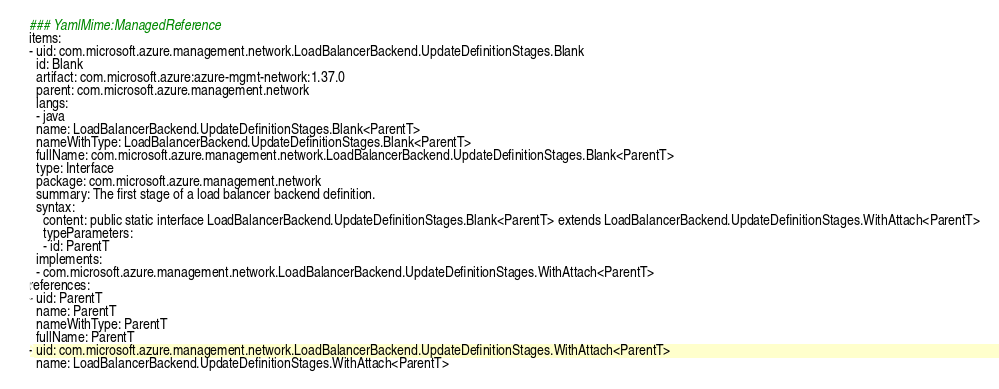Convert code to text. <code><loc_0><loc_0><loc_500><loc_500><_YAML_>### YamlMime:ManagedReference
items:
- uid: com.microsoft.azure.management.network.LoadBalancerBackend.UpdateDefinitionStages.Blank
  id: Blank
  artifact: com.microsoft.azure:azure-mgmt-network:1.37.0
  parent: com.microsoft.azure.management.network
  langs:
  - java
  name: LoadBalancerBackend.UpdateDefinitionStages.Blank<ParentT>
  nameWithType: LoadBalancerBackend.UpdateDefinitionStages.Blank<ParentT>
  fullName: com.microsoft.azure.management.network.LoadBalancerBackend.UpdateDefinitionStages.Blank<ParentT>
  type: Interface
  package: com.microsoft.azure.management.network
  summary: The first stage of a load balancer backend definition.
  syntax:
    content: public static interface LoadBalancerBackend.UpdateDefinitionStages.Blank<ParentT> extends LoadBalancerBackend.UpdateDefinitionStages.WithAttach<ParentT>
    typeParameters:
    - id: ParentT
  implements:
  - com.microsoft.azure.management.network.LoadBalancerBackend.UpdateDefinitionStages.WithAttach<ParentT>
references:
- uid: ParentT
  name: ParentT
  nameWithType: ParentT
  fullName: ParentT
- uid: com.microsoft.azure.management.network.LoadBalancerBackend.UpdateDefinitionStages.WithAttach<ParentT>
  name: LoadBalancerBackend.UpdateDefinitionStages.WithAttach<ParentT></code> 